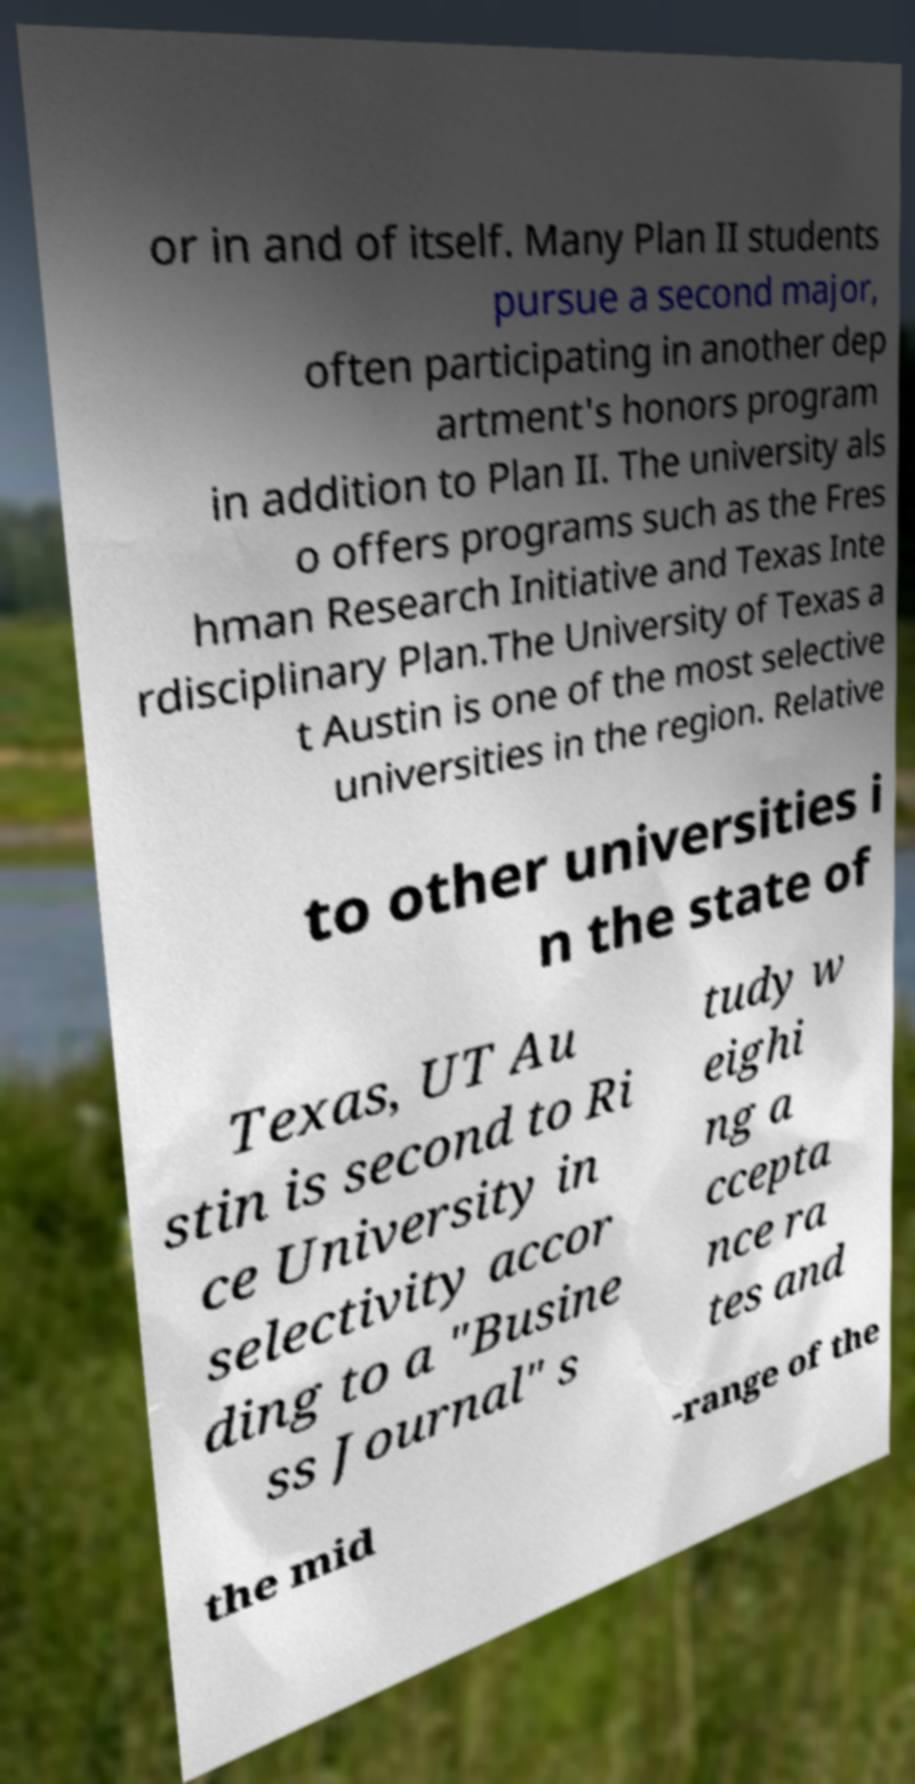Could you extract and type out the text from this image? or in and of itself. Many Plan II students pursue a second major, often participating in another dep artment's honors program in addition to Plan II. The university als o offers programs such as the Fres hman Research Initiative and Texas Inte rdisciplinary Plan.The University of Texas a t Austin is one of the most selective universities in the region. Relative to other universities i n the state of Texas, UT Au stin is second to Ri ce University in selectivity accor ding to a "Busine ss Journal" s tudy w eighi ng a ccepta nce ra tes and the mid -range of the 